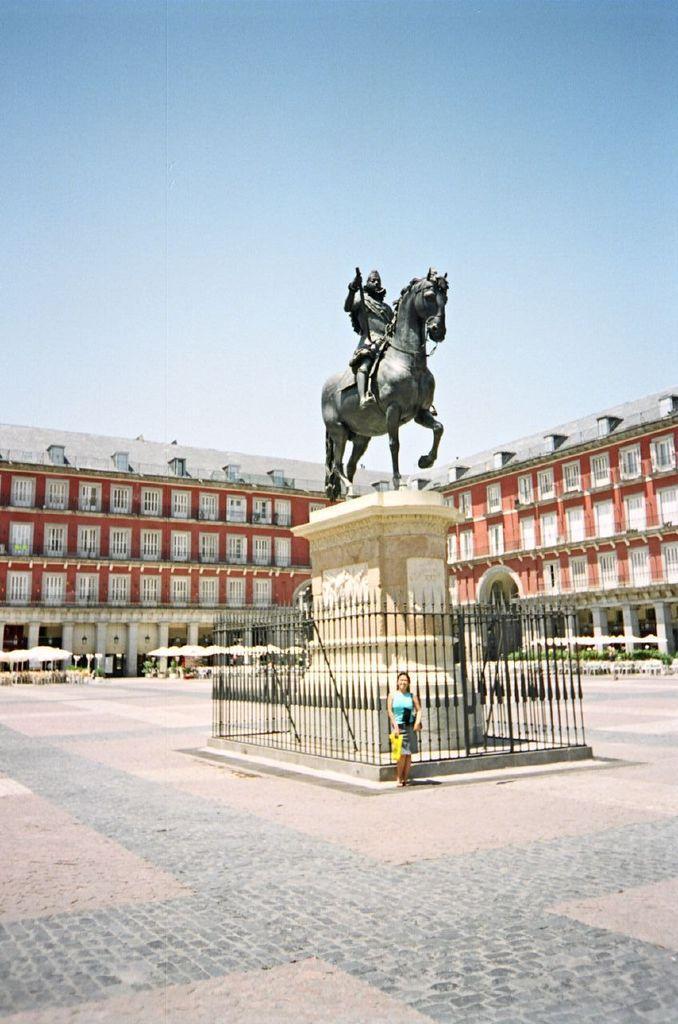Could you give a brief overview of what you see in this image? In this picture there is a building and there are umbrellas and trees. In the foreground there is a statute of a person sitting on the horse and there is a woman standing at the railing. At the top there is sky. At the bottom there is a road. 